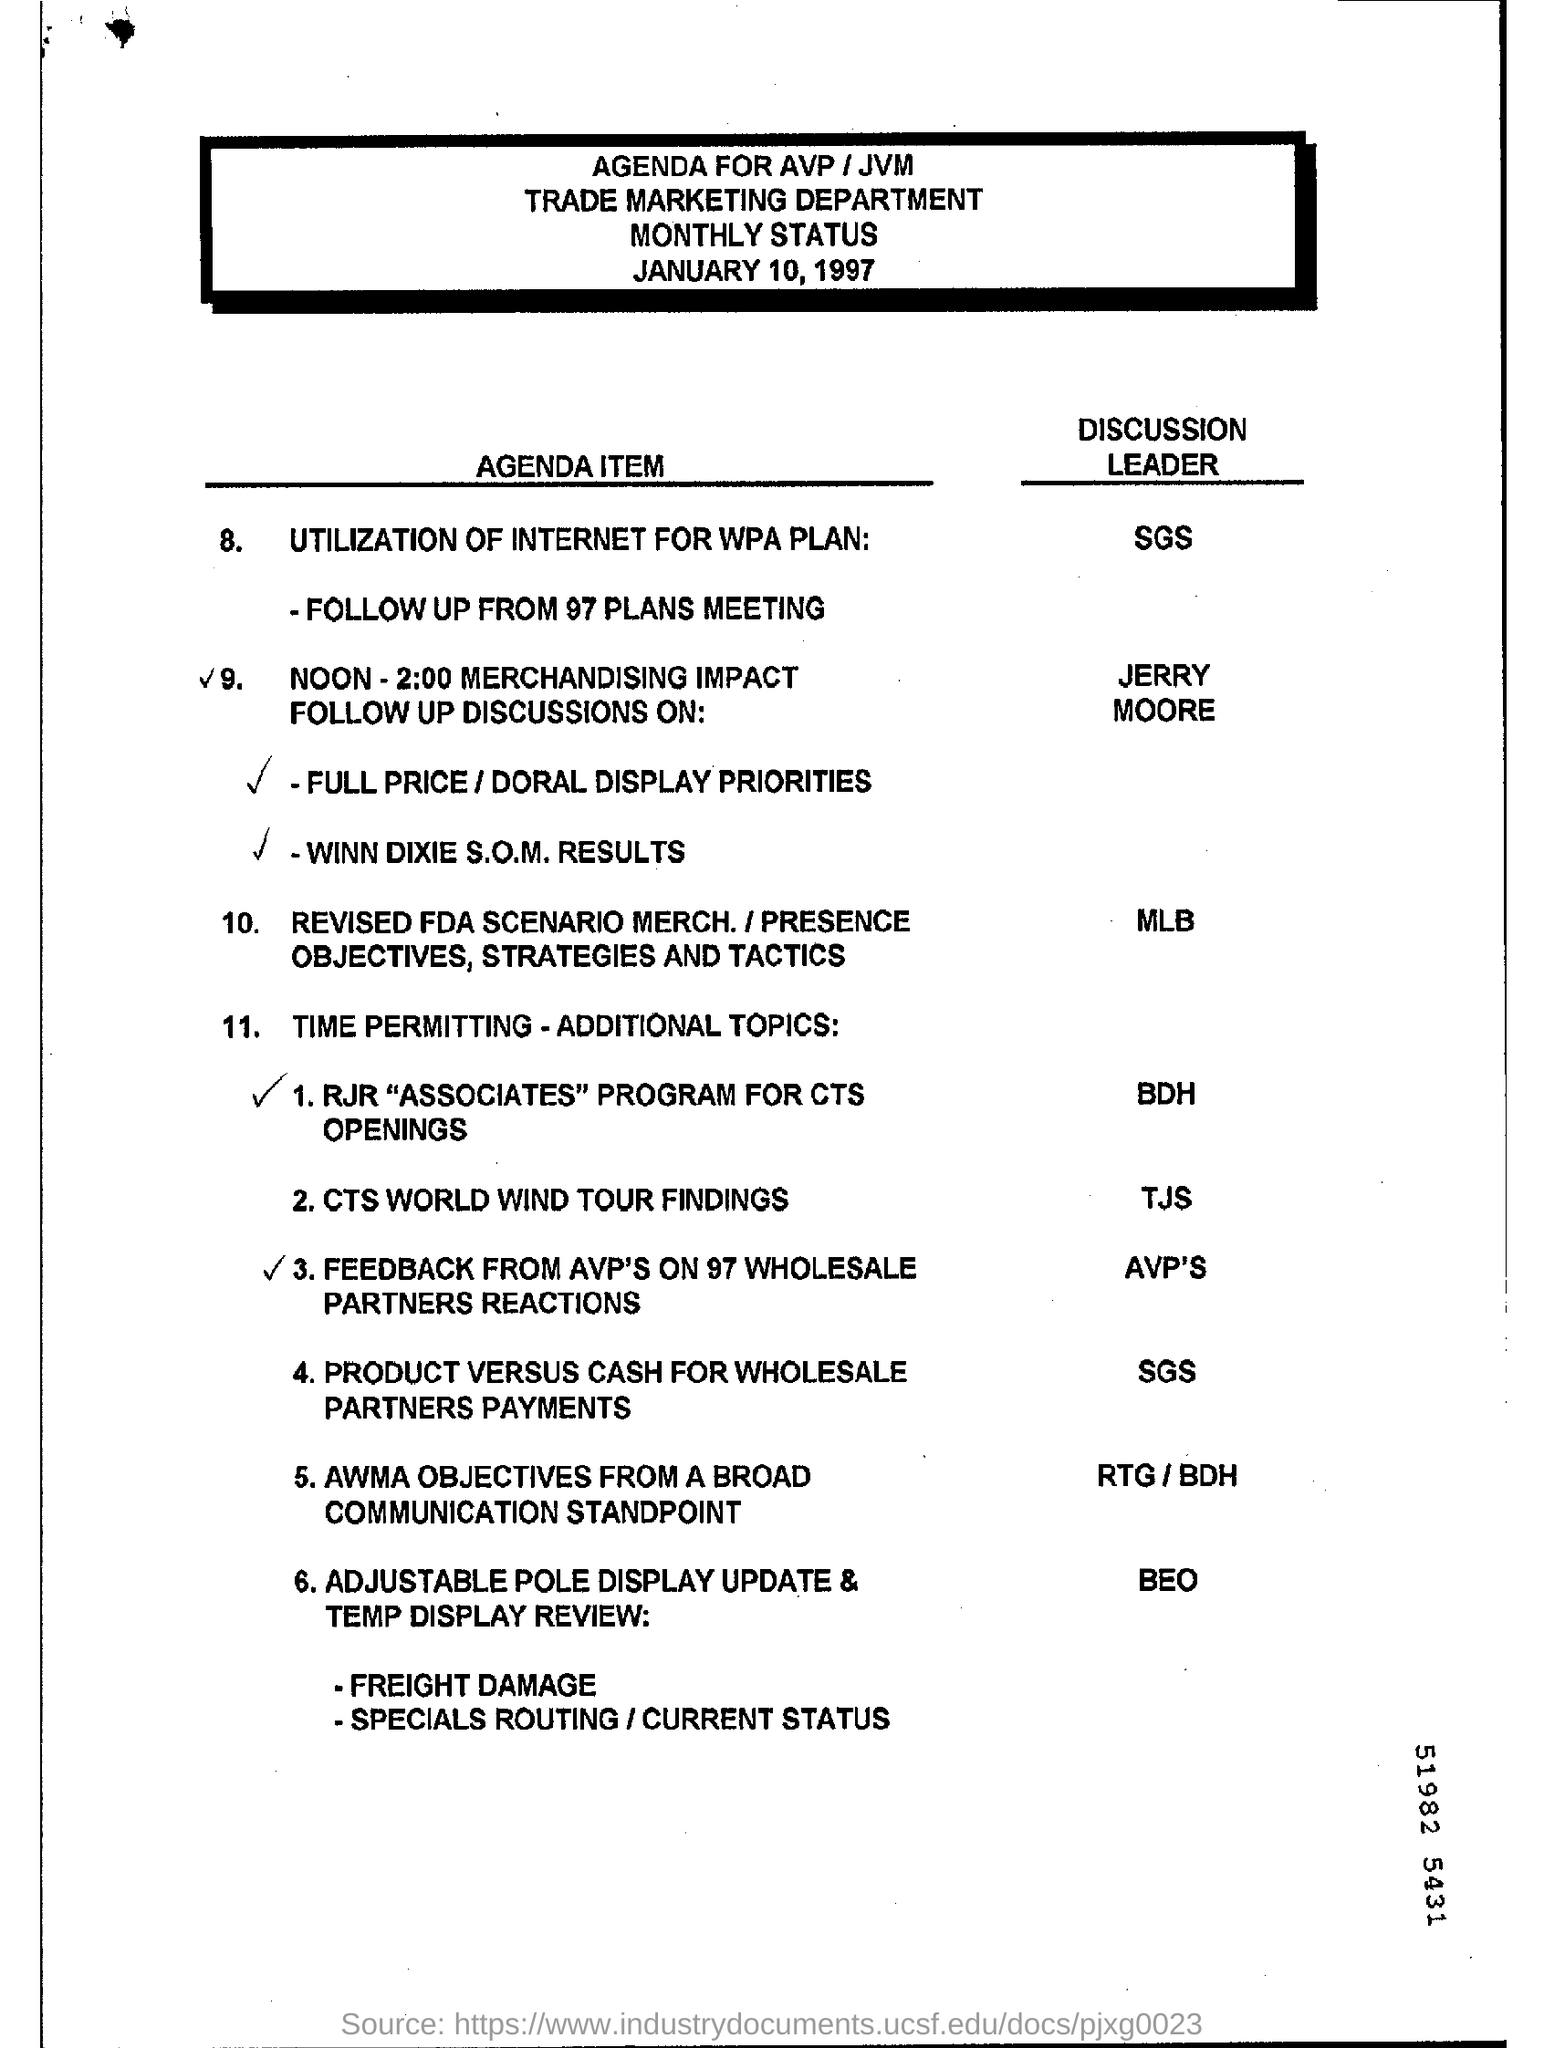Identify some key points in this picture. The discussion leader for the utilization of the internet for the WPA plan is SGS. The marketing department is responsible for the overall planning, execution, and management of marketing campaigns and initiatives to promote the company's products and services to potential customers. The trade marketing department specifically focuses on promoting the company's products to wholesalers and retailers in order to increase sales and distribution. 